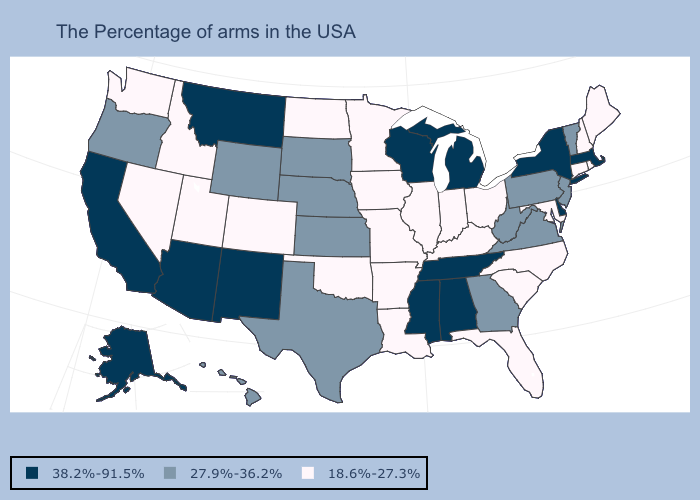Name the states that have a value in the range 38.2%-91.5%?
Answer briefly. Massachusetts, New York, Delaware, Michigan, Alabama, Tennessee, Wisconsin, Mississippi, New Mexico, Montana, Arizona, California, Alaska. Which states have the lowest value in the USA?
Answer briefly. Maine, Rhode Island, New Hampshire, Connecticut, Maryland, North Carolina, South Carolina, Ohio, Florida, Kentucky, Indiana, Illinois, Louisiana, Missouri, Arkansas, Minnesota, Iowa, Oklahoma, North Dakota, Colorado, Utah, Idaho, Nevada, Washington. Name the states that have a value in the range 38.2%-91.5%?
Give a very brief answer. Massachusetts, New York, Delaware, Michigan, Alabama, Tennessee, Wisconsin, Mississippi, New Mexico, Montana, Arizona, California, Alaska. What is the value of Wisconsin?
Short answer required. 38.2%-91.5%. Does Delaware have the lowest value in the South?
Write a very short answer. No. Does Minnesota have the lowest value in the USA?
Answer briefly. Yes. Name the states that have a value in the range 18.6%-27.3%?
Answer briefly. Maine, Rhode Island, New Hampshire, Connecticut, Maryland, North Carolina, South Carolina, Ohio, Florida, Kentucky, Indiana, Illinois, Louisiana, Missouri, Arkansas, Minnesota, Iowa, Oklahoma, North Dakota, Colorado, Utah, Idaho, Nevada, Washington. What is the lowest value in states that border Florida?
Quick response, please. 27.9%-36.2%. What is the value of New Hampshire?
Short answer required. 18.6%-27.3%. What is the highest value in the USA?
Answer briefly. 38.2%-91.5%. Name the states that have a value in the range 38.2%-91.5%?
Short answer required. Massachusetts, New York, Delaware, Michigan, Alabama, Tennessee, Wisconsin, Mississippi, New Mexico, Montana, Arizona, California, Alaska. What is the lowest value in states that border Maryland?
Be succinct. 27.9%-36.2%. Is the legend a continuous bar?
Give a very brief answer. No. Does Idaho have the highest value in the USA?
Keep it brief. No. 